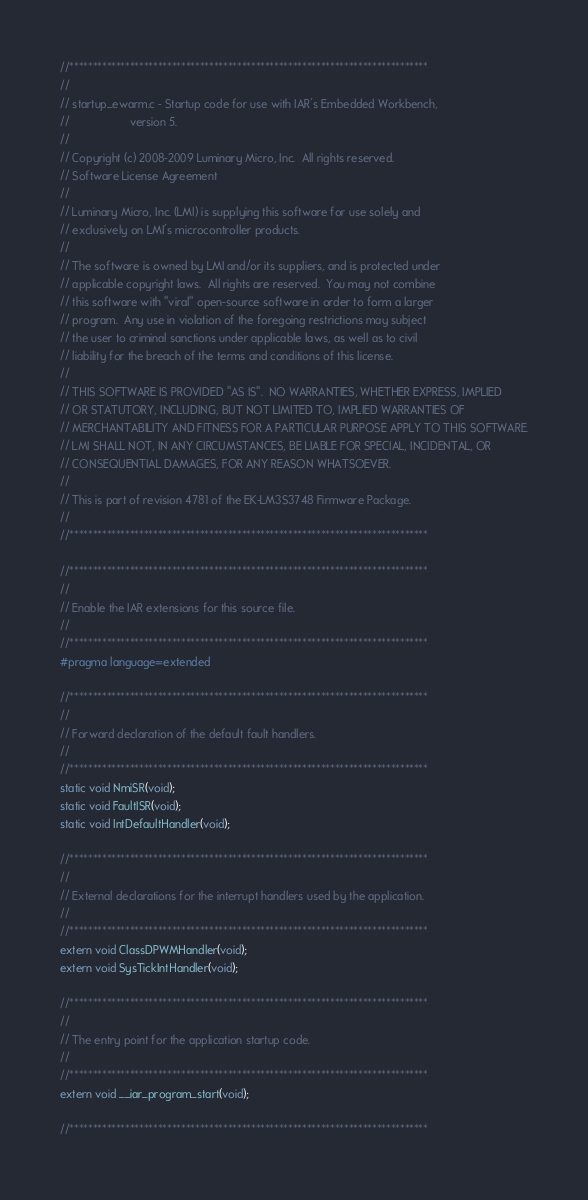Convert code to text. <code><loc_0><loc_0><loc_500><loc_500><_C_>//*****************************************************************************
//
// startup_ewarm.c - Startup code for use with IAR's Embedded Workbench,
//                   version 5.
//
// Copyright (c) 2008-2009 Luminary Micro, Inc.  All rights reserved.
// Software License Agreement
// 
// Luminary Micro, Inc. (LMI) is supplying this software for use solely and
// exclusively on LMI's microcontroller products.
// 
// The software is owned by LMI and/or its suppliers, and is protected under
// applicable copyright laws.  All rights are reserved.  You may not combine
// this software with "viral" open-source software in order to form a larger
// program.  Any use in violation of the foregoing restrictions may subject
// the user to criminal sanctions under applicable laws, as well as to civil
// liability for the breach of the terms and conditions of this license.
// 
// THIS SOFTWARE IS PROVIDED "AS IS".  NO WARRANTIES, WHETHER EXPRESS, IMPLIED
// OR STATUTORY, INCLUDING, BUT NOT LIMITED TO, IMPLIED WARRANTIES OF
// MERCHANTABILITY AND FITNESS FOR A PARTICULAR PURPOSE APPLY TO THIS SOFTWARE.
// LMI SHALL NOT, IN ANY CIRCUMSTANCES, BE LIABLE FOR SPECIAL, INCIDENTAL, OR
// CONSEQUENTIAL DAMAGES, FOR ANY REASON WHATSOEVER.
// 
// This is part of revision 4781 of the EK-LM3S3748 Firmware Package.
//
//*****************************************************************************

//*****************************************************************************
//
// Enable the IAR extensions for this source file.
//
//*****************************************************************************
#pragma language=extended

//*****************************************************************************
//
// Forward declaration of the default fault handlers.
//
//*****************************************************************************
static void NmiSR(void);
static void FaultISR(void);
static void IntDefaultHandler(void);

//*****************************************************************************
//
// External declarations for the interrupt handlers used by the application.
//
//*****************************************************************************
extern void ClassDPWMHandler(void);
extern void SysTickIntHandler(void);

//*****************************************************************************
//
// The entry point for the application startup code.
//
//*****************************************************************************
extern void __iar_program_start(void);

//*****************************************************************************</code> 